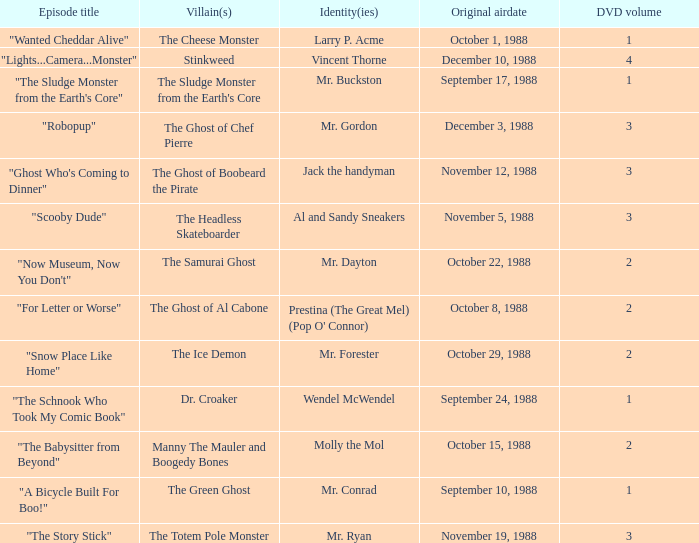Name the episode that aired october 8, 1988 "For Letter or Worse". 